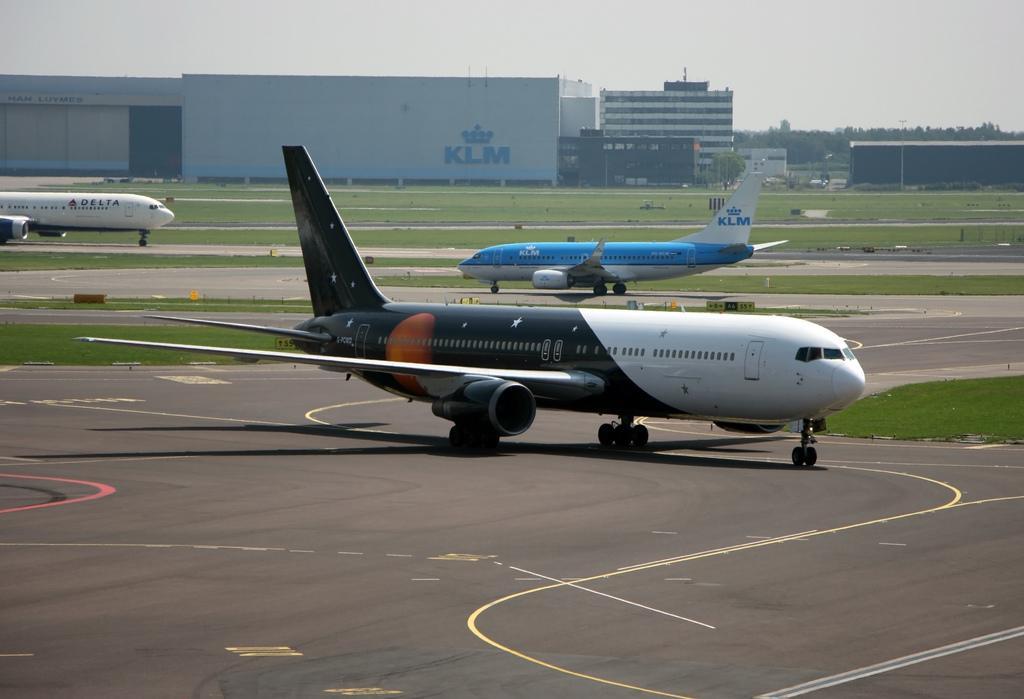Could you give a brief overview of what you see in this image? In this image I can see the aircraft on the ground. In the background, I can see the buildings and the sky. 